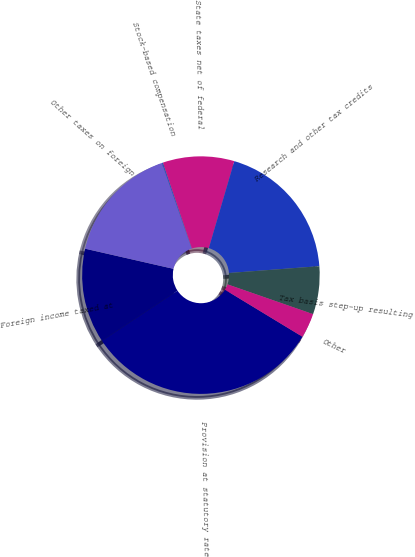Convert chart to OTSL. <chart><loc_0><loc_0><loc_500><loc_500><pie_chart><fcel>Provision at statutory rate<fcel>Foreign income taxed at<fcel>Other taxes on foreign<fcel>Stock-based compensation<fcel>State taxes net of federal<fcel>Research and other tax credits<fcel>Tax basis step-up resulting<fcel>Other<nl><fcel>31.99%<fcel>12.9%<fcel>16.08%<fcel>0.17%<fcel>9.72%<fcel>19.26%<fcel>6.53%<fcel>3.35%<nl></chart> 